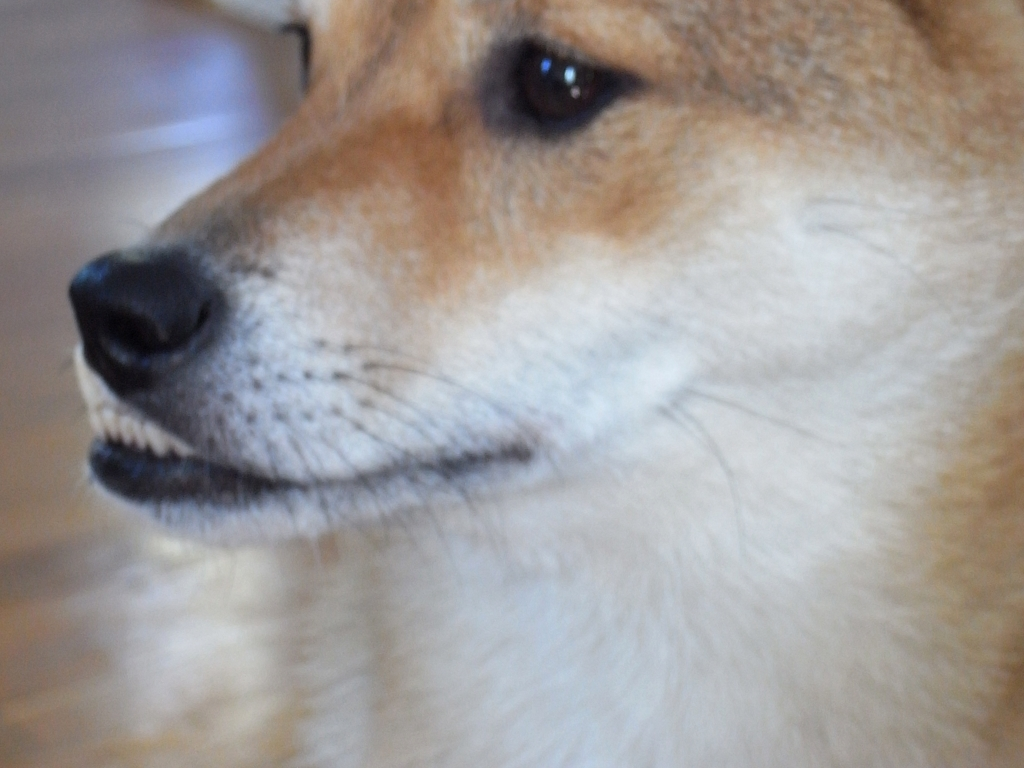Are there any notable details about the dog's breed or appearance? From the visible features in the image, the dog appears to possess physical traits common to certain spitz-type breeds. These include a dense fur coat, erect ears, and a pointed muzzle. However, without a full view of the dog's body and size, it's challenging to determine the exact breed. The visible coat colors and patterns, the alert facial expression, and the overall bearing of the dog are distinctive and contribute to its unique appearance. 